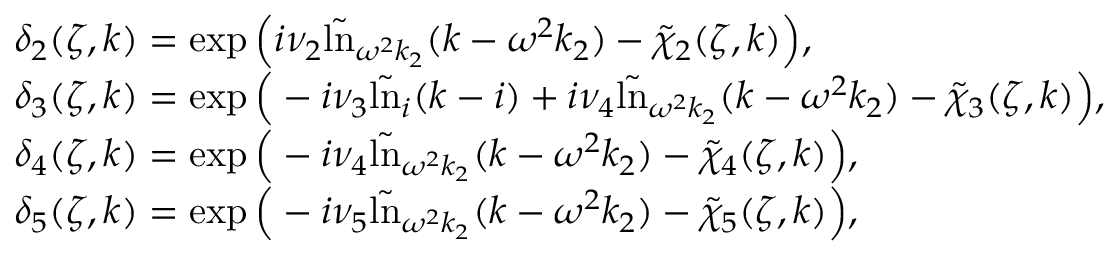<formula> <loc_0><loc_0><loc_500><loc_500>\begin{array} { r l } & { \delta _ { 2 } ( \zeta , k ) = \exp \left ( i \nu _ { 2 } \tilde { \ln } _ { \omega ^ { 2 } k _ { 2 } } ( k - \omega ^ { 2 } k _ { 2 } ) - \tilde { \chi } _ { 2 } ( \zeta , k ) \right ) , } \\ & { \delta _ { 3 } ( \zeta , k ) = \exp \left ( - i \nu _ { 3 } \tilde { \ln } _ { i } ( k - i ) + i \nu _ { 4 } \tilde { \ln } _ { \omega ^ { 2 } k _ { 2 } } ( k - \omega ^ { 2 } k _ { 2 } ) - \tilde { \chi } _ { 3 } ( \zeta , k ) \right ) , } \\ & { \delta _ { 4 } ( \zeta , k ) = \exp \left ( - i \nu _ { 4 } \tilde { \ln } _ { \omega ^ { 2 } k _ { 2 } } ( k - \omega ^ { 2 } k _ { 2 } ) - \tilde { \chi } _ { 4 } ( \zeta , k ) \right ) , } \\ & { \delta _ { 5 } ( \zeta , k ) = \exp \left ( - i \nu _ { 5 } \tilde { \ln } _ { \omega ^ { 2 } k _ { 2 } } ( k - \omega ^ { 2 } k _ { 2 } ) - \tilde { \chi } _ { 5 } ( \zeta , k ) \right ) , } \end{array}</formula> 